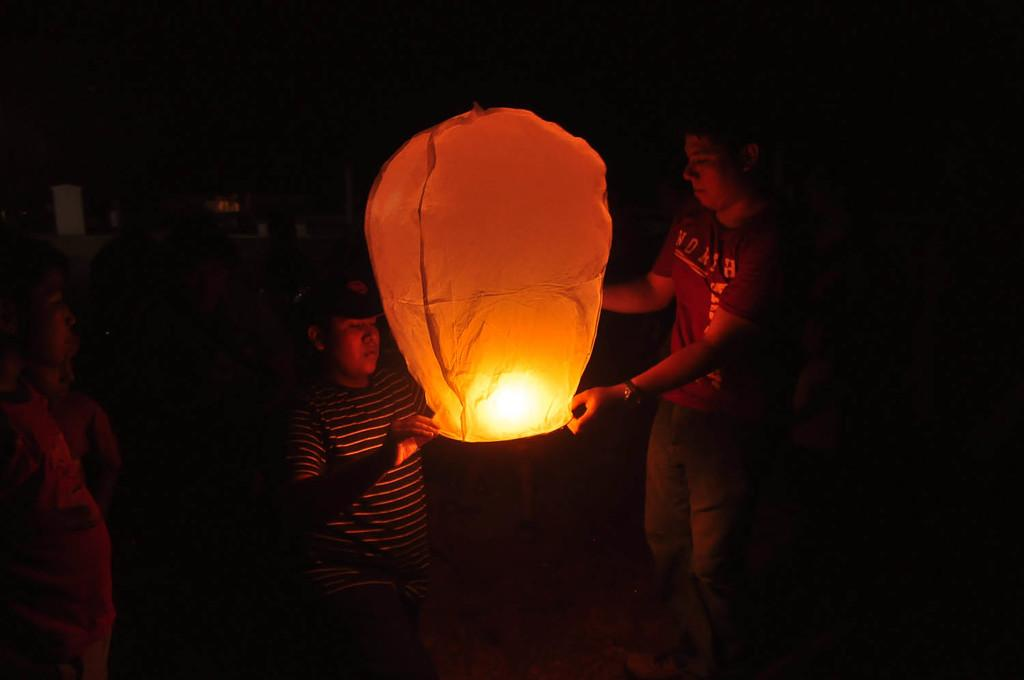What is the overall lighting condition in the image? The image is dark. What can be seen in the image besides the lighting condition? There are people standing in the image. What are the people wearing? The people are wearing clothes. Can you identify any accessories in the image? Yes, there is a wrist watch and a cap in the image. What additional object is present in the image? There is a paper sky lantern in the image. What advice does the grandmother give to the parent in the image? There is no grandmother or parent present in the image, so it is not possible to answer this question. 